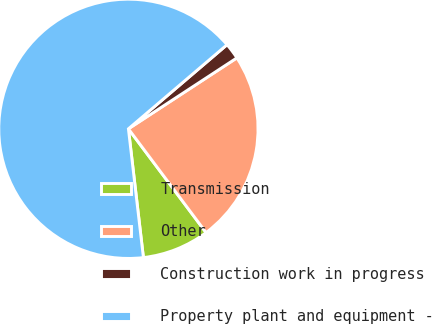Convert chart. <chart><loc_0><loc_0><loc_500><loc_500><pie_chart><fcel>Transmission<fcel>Other<fcel>Construction work in progress<fcel>Property plant and equipment -<nl><fcel>8.38%<fcel>23.99%<fcel>2.02%<fcel>65.61%<nl></chart> 